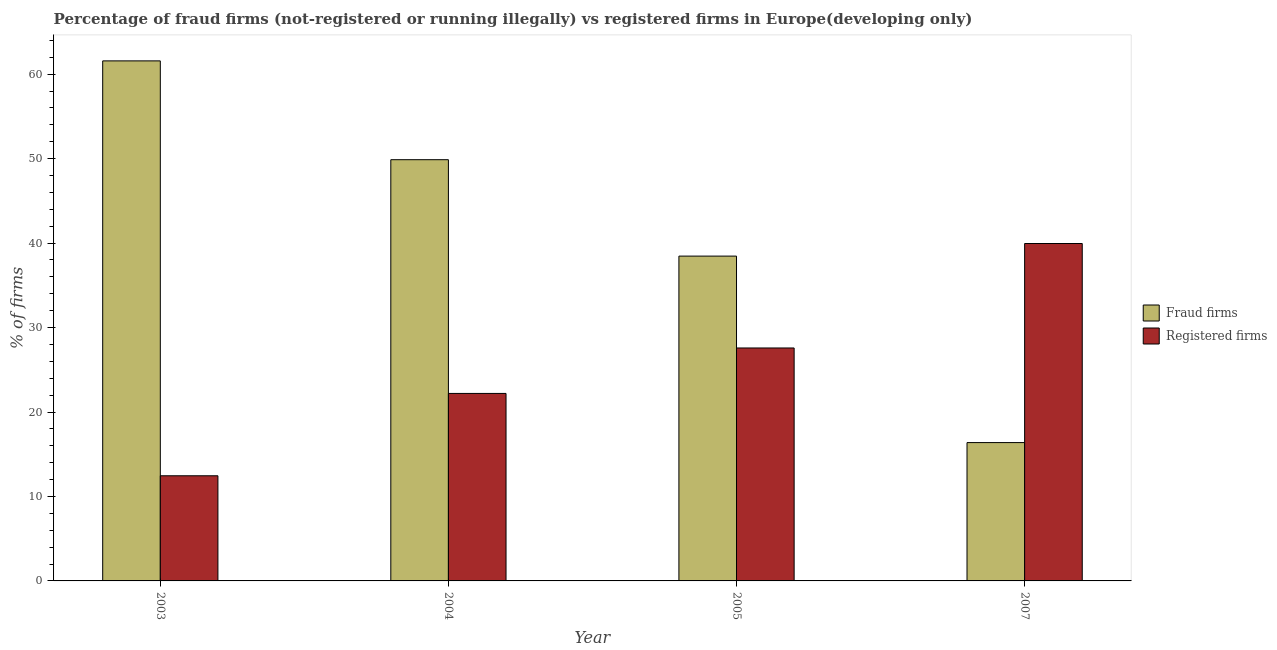Are the number of bars per tick equal to the number of legend labels?
Your answer should be compact. Yes. How many bars are there on the 2nd tick from the left?
Offer a terse response. 2. How many bars are there on the 2nd tick from the right?
Give a very brief answer. 2. In how many cases, is the number of bars for a given year not equal to the number of legend labels?
Provide a succinct answer. 0. What is the percentage of registered firms in 2007?
Your answer should be compact. 39.95. Across all years, what is the maximum percentage of registered firms?
Your answer should be compact. 39.95. Across all years, what is the minimum percentage of registered firms?
Offer a very short reply. 12.45. In which year was the percentage of fraud firms minimum?
Your answer should be compact. 2007. What is the total percentage of fraud firms in the graph?
Give a very brief answer. 166.29. What is the difference between the percentage of fraud firms in 2004 and that in 2005?
Offer a terse response. 11.41. What is the difference between the percentage of registered firms in 2003 and the percentage of fraud firms in 2007?
Make the answer very short. -27.5. What is the average percentage of registered firms per year?
Give a very brief answer. 25.55. In the year 2003, what is the difference between the percentage of fraud firms and percentage of registered firms?
Provide a succinct answer. 0. What is the ratio of the percentage of registered firms in 2003 to that in 2004?
Provide a short and direct response. 0.56. Is the difference between the percentage of fraud firms in 2003 and 2004 greater than the difference between the percentage of registered firms in 2003 and 2004?
Provide a succinct answer. No. What is the difference between the highest and the second highest percentage of fraud firms?
Offer a terse response. 11.7. What is the difference between the highest and the lowest percentage of fraud firms?
Your answer should be compact. 45.2. Is the sum of the percentage of fraud firms in 2004 and 2005 greater than the maximum percentage of registered firms across all years?
Your response must be concise. Yes. What does the 2nd bar from the left in 2007 represents?
Your response must be concise. Registered firms. What does the 1st bar from the right in 2005 represents?
Give a very brief answer. Registered firms. How many bars are there?
Make the answer very short. 8. What is the difference between two consecutive major ticks on the Y-axis?
Provide a short and direct response. 10. Does the graph contain any zero values?
Your answer should be compact. No. Does the graph contain grids?
Provide a succinct answer. No. Where does the legend appear in the graph?
Make the answer very short. Center right. How many legend labels are there?
Provide a short and direct response. 2. How are the legend labels stacked?
Make the answer very short. Vertical. What is the title of the graph?
Offer a very short reply. Percentage of fraud firms (not-registered or running illegally) vs registered firms in Europe(developing only). What is the label or title of the Y-axis?
Offer a terse response. % of firms. What is the % of firms of Fraud firms in 2003?
Offer a very short reply. 61.58. What is the % of firms of Registered firms in 2003?
Offer a terse response. 12.45. What is the % of firms of Fraud firms in 2004?
Provide a succinct answer. 49.88. What is the % of firms of Registered firms in 2004?
Your answer should be very brief. 22.2. What is the % of firms in Fraud firms in 2005?
Make the answer very short. 38.46. What is the % of firms of Registered firms in 2005?
Your response must be concise. 27.58. What is the % of firms of Fraud firms in 2007?
Offer a terse response. 16.38. What is the % of firms in Registered firms in 2007?
Your answer should be compact. 39.95. Across all years, what is the maximum % of firms in Fraud firms?
Your response must be concise. 61.58. Across all years, what is the maximum % of firms in Registered firms?
Provide a short and direct response. 39.95. Across all years, what is the minimum % of firms of Fraud firms?
Ensure brevity in your answer.  16.38. Across all years, what is the minimum % of firms of Registered firms?
Provide a succinct answer. 12.45. What is the total % of firms in Fraud firms in the graph?
Provide a succinct answer. 166.29. What is the total % of firms in Registered firms in the graph?
Give a very brief answer. 102.18. What is the difference between the % of firms in Fraud firms in 2003 and that in 2004?
Provide a short and direct response. 11.7. What is the difference between the % of firms of Registered firms in 2003 and that in 2004?
Offer a very short reply. -9.75. What is the difference between the % of firms in Fraud firms in 2003 and that in 2005?
Your answer should be very brief. 23.11. What is the difference between the % of firms in Registered firms in 2003 and that in 2005?
Keep it short and to the point. -15.13. What is the difference between the % of firms of Fraud firms in 2003 and that in 2007?
Provide a succinct answer. 45.2. What is the difference between the % of firms of Registered firms in 2003 and that in 2007?
Provide a succinct answer. -27.5. What is the difference between the % of firms in Fraud firms in 2004 and that in 2005?
Make the answer very short. 11.41. What is the difference between the % of firms of Registered firms in 2004 and that in 2005?
Your answer should be very brief. -5.38. What is the difference between the % of firms in Fraud firms in 2004 and that in 2007?
Provide a short and direct response. 33.49. What is the difference between the % of firms of Registered firms in 2004 and that in 2007?
Provide a succinct answer. -17.75. What is the difference between the % of firms of Fraud firms in 2005 and that in 2007?
Keep it short and to the point. 22.08. What is the difference between the % of firms of Registered firms in 2005 and that in 2007?
Provide a short and direct response. -12.37. What is the difference between the % of firms in Fraud firms in 2003 and the % of firms in Registered firms in 2004?
Offer a terse response. 39.38. What is the difference between the % of firms in Fraud firms in 2003 and the % of firms in Registered firms in 2005?
Provide a succinct answer. 33.99. What is the difference between the % of firms of Fraud firms in 2003 and the % of firms of Registered firms in 2007?
Provide a short and direct response. 21.62. What is the difference between the % of firms in Fraud firms in 2004 and the % of firms in Registered firms in 2005?
Provide a short and direct response. 22.29. What is the difference between the % of firms of Fraud firms in 2004 and the % of firms of Registered firms in 2007?
Your response must be concise. 9.93. What is the difference between the % of firms of Fraud firms in 2005 and the % of firms of Registered firms in 2007?
Keep it short and to the point. -1.49. What is the average % of firms in Fraud firms per year?
Your answer should be very brief. 41.57. What is the average % of firms in Registered firms per year?
Your answer should be very brief. 25.55. In the year 2003, what is the difference between the % of firms in Fraud firms and % of firms in Registered firms?
Provide a short and direct response. 49.12. In the year 2004, what is the difference between the % of firms in Fraud firms and % of firms in Registered firms?
Offer a terse response. 27.68. In the year 2005, what is the difference between the % of firms of Fraud firms and % of firms of Registered firms?
Keep it short and to the point. 10.88. In the year 2007, what is the difference between the % of firms of Fraud firms and % of firms of Registered firms?
Make the answer very short. -23.57. What is the ratio of the % of firms in Fraud firms in 2003 to that in 2004?
Offer a very short reply. 1.23. What is the ratio of the % of firms of Registered firms in 2003 to that in 2004?
Your answer should be very brief. 0.56. What is the ratio of the % of firms of Fraud firms in 2003 to that in 2005?
Provide a succinct answer. 1.6. What is the ratio of the % of firms in Registered firms in 2003 to that in 2005?
Make the answer very short. 0.45. What is the ratio of the % of firms of Fraud firms in 2003 to that in 2007?
Provide a short and direct response. 3.76. What is the ratio of the % of firms of Registered firms in 2003 to that in 2007?
Your answer should be very brief. 0.31. What is the ratio of the % of firms of Fraud firms in 2004 to that in 2005?
Give a very brief answer. 1.3. What is the ratio of the % of firms in Registered firms in 2004 to that in 2005?
Your answer should be compact. 0.8. What is the ratio of the % of firms in Fraud firms in 2004 to that in 2007?
Provide a succinct answer. 3.04. What is the ratio of the % of firms of Registered firms in 2004 to that in 2007?
Ensure brevity in your answer.  0.56. What is the ratio of the % of firms of Fraud firms in 2005 to that in 2007?
Give a very brief answer. 2.35. What is the ratio of the % of firms in Registered firms in 2005 to that in 2007?
Keep it short and to the point. 0.69. What is the difference between the highest and the second highest % of firms of Registered firms?
Your response must be concise. 12.37. What is the difference between the highest and the lowest % of firms in Fraud firms?
Provide a succinct answer. 45.2. What is the difference between the highest and the lowest % of firms of Registered firms?
Give a very brief answer. 27.5. 